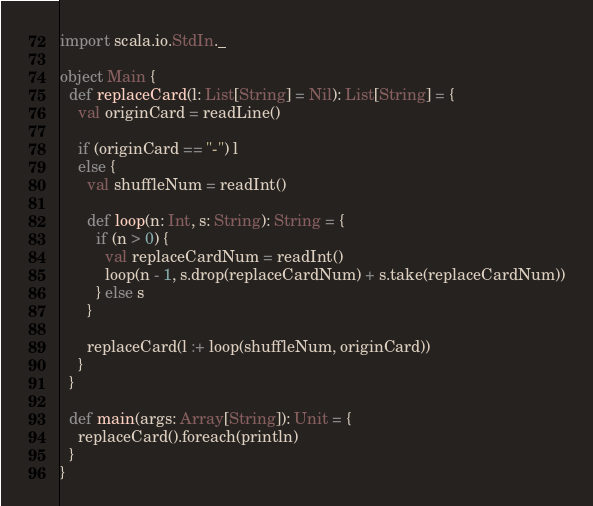Convert code to text. <code><loc_0><loc_0><loc_500><loc_500><_Scala_>import scala.io.StdIn._

object Main {
  def replaceCard(l: List[String] = Nil): List[String] = {
    val originCard = readLine()

    if (originCard == "-") l
    else {
      val shuffleNum = readInt()

      def loop(n: Int, s: String): String = {
        if (n > 0) {
          val replaceCardNum = readInt()
          loop(n - 1, s.drop(replaceCardNum) + s.take(replaceCardNum))
        } else s
      }

      replaceCard(l :+ loop(shuffleNum, originCard))
    }
  }

  def main(args: Array[String]): Unit = {
    replaceCard().foreach(println)
  }
}</code> 